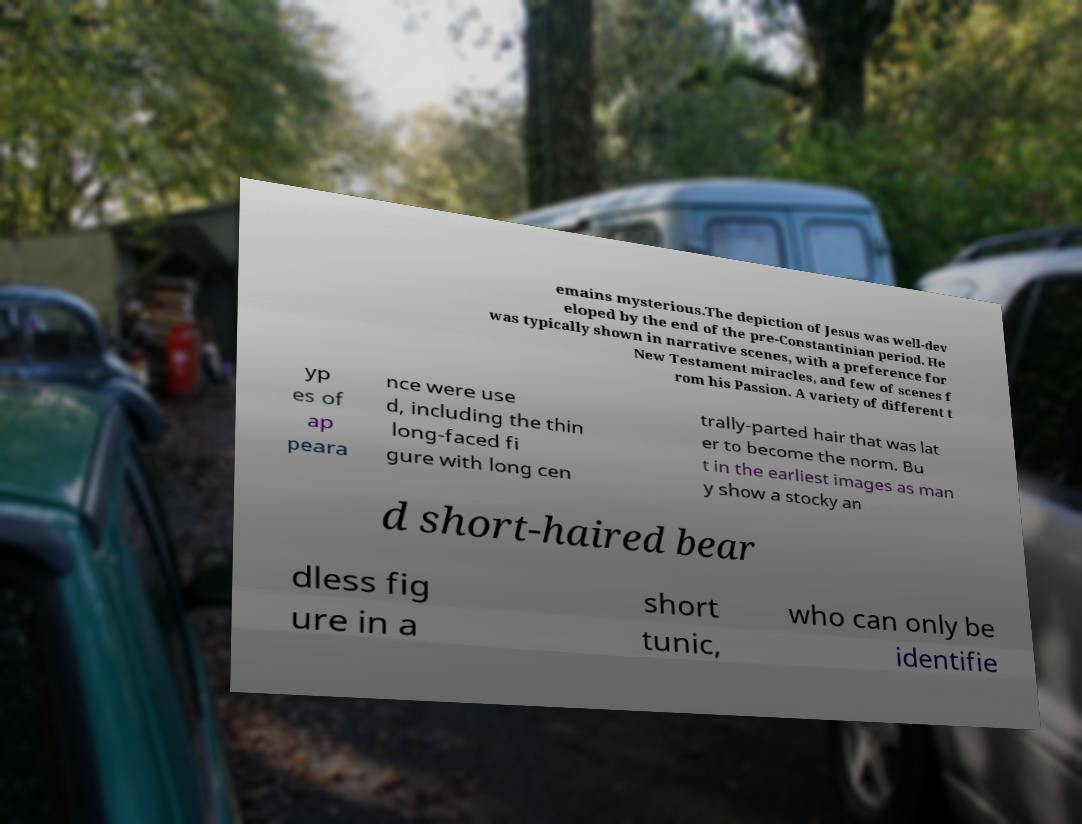Can you read and provide the text displayed in the image?This photo seems to have some interesting text. Can you extract and type it out for me? emains mysterious.The depiction of Jesus was well-dev eloped by the end of the pre-Constantinian period. He was typically shown in narrative scenes, with a preference for New Testament miracles, and few of scenes f rom his Passion. A variety of different t yp es of ap peara nce were use d, including the thin long-faced fi gure with long cen trally-parted hair that was lat er to become the norm. Bu t in the earliest images as man y show a stocky an d short-haired bear dless fig ure in a short tunic, who can only be identifie 